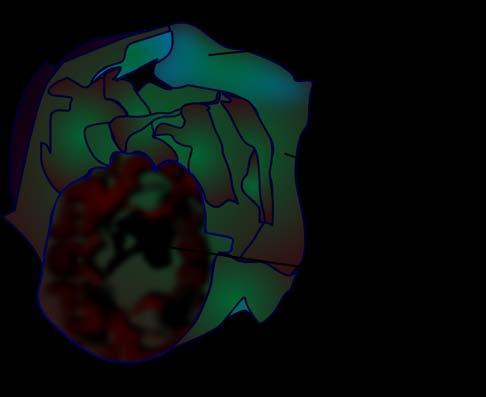does rest of the hepatic parenchyma in the upper part of the picture show presence of loculi containing gelatinous mucoid material?
Answer the question using a single word or phrase. No 